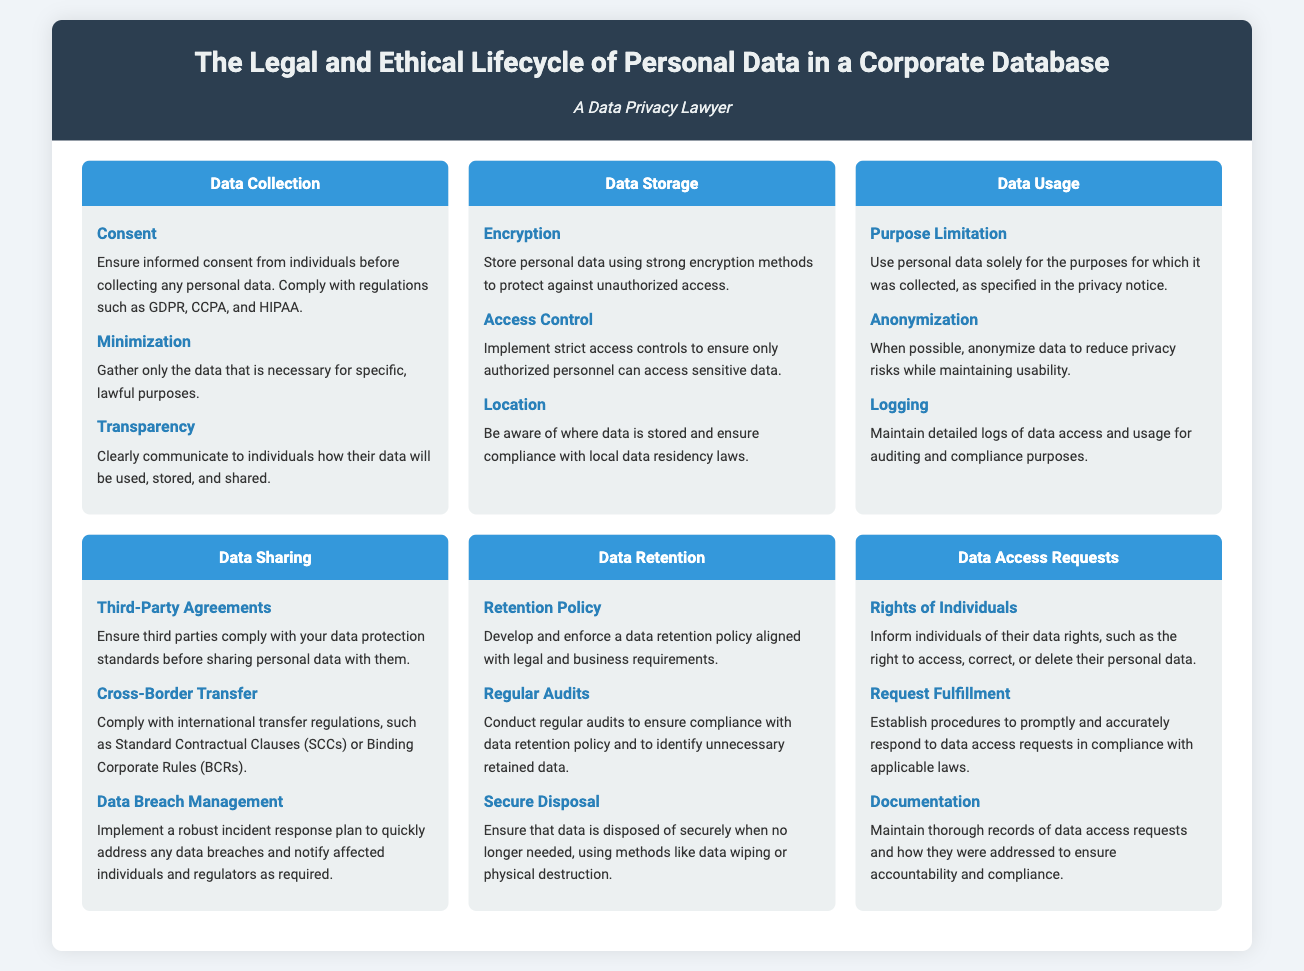what is the first phase of the data lifecycle? The first phase of the data lifecycle is Data Collection, which focuses on gathering personal data responsibly.
Answer: Data Collection what is the key detail under Data Sharing that involves third parties? Under Data Sharing, ensuring third-party agreements includes requiring third parties to comply with data protection standards before sharing personal data.
Answer: Third-Party Agreements how can data be secured during the Data Storage phase? Strong encryption methods are recommended to protect personal data against unauthorized access during the Data Storage phase.
Answer: Encryption what is the main goal of Purpose Limitation in Data Usage? The main goal of Purpose Limitation in Data Usage is to ensure personal data is used solely for its originally specified purposes.
Answer: Use solely for original purposes how should data be disposed of when no longer needed? Data should be disposed of securely using methods like data wiping or physical destruction when no longer needed.
Answer: Securely using data wiping or destruction which phase addresses individual rights concerning personal data? The phase that addresses individual rights concerning personal data is Data Access Requests, which informs individuals of their rights.
Answer: Data Access Requests what should be established for responding to data access requests? Procedures should be established to promptly and accurately respond to data access requests in compliance with applicable laws.
Answer: Procedures to respond what is the purpose of implementing strict access controls in Data Storage? The purpose of implementing strict access controls is to ensure that only authorized personnel can access sensitive data.
Answer: Ensure only authorized access how often should audits be conducted to ensure data retention compliance? Regular audits should be conducted to ensure compliance with data retention policy and identify unnecessary retained data.
Answer: Regularly 